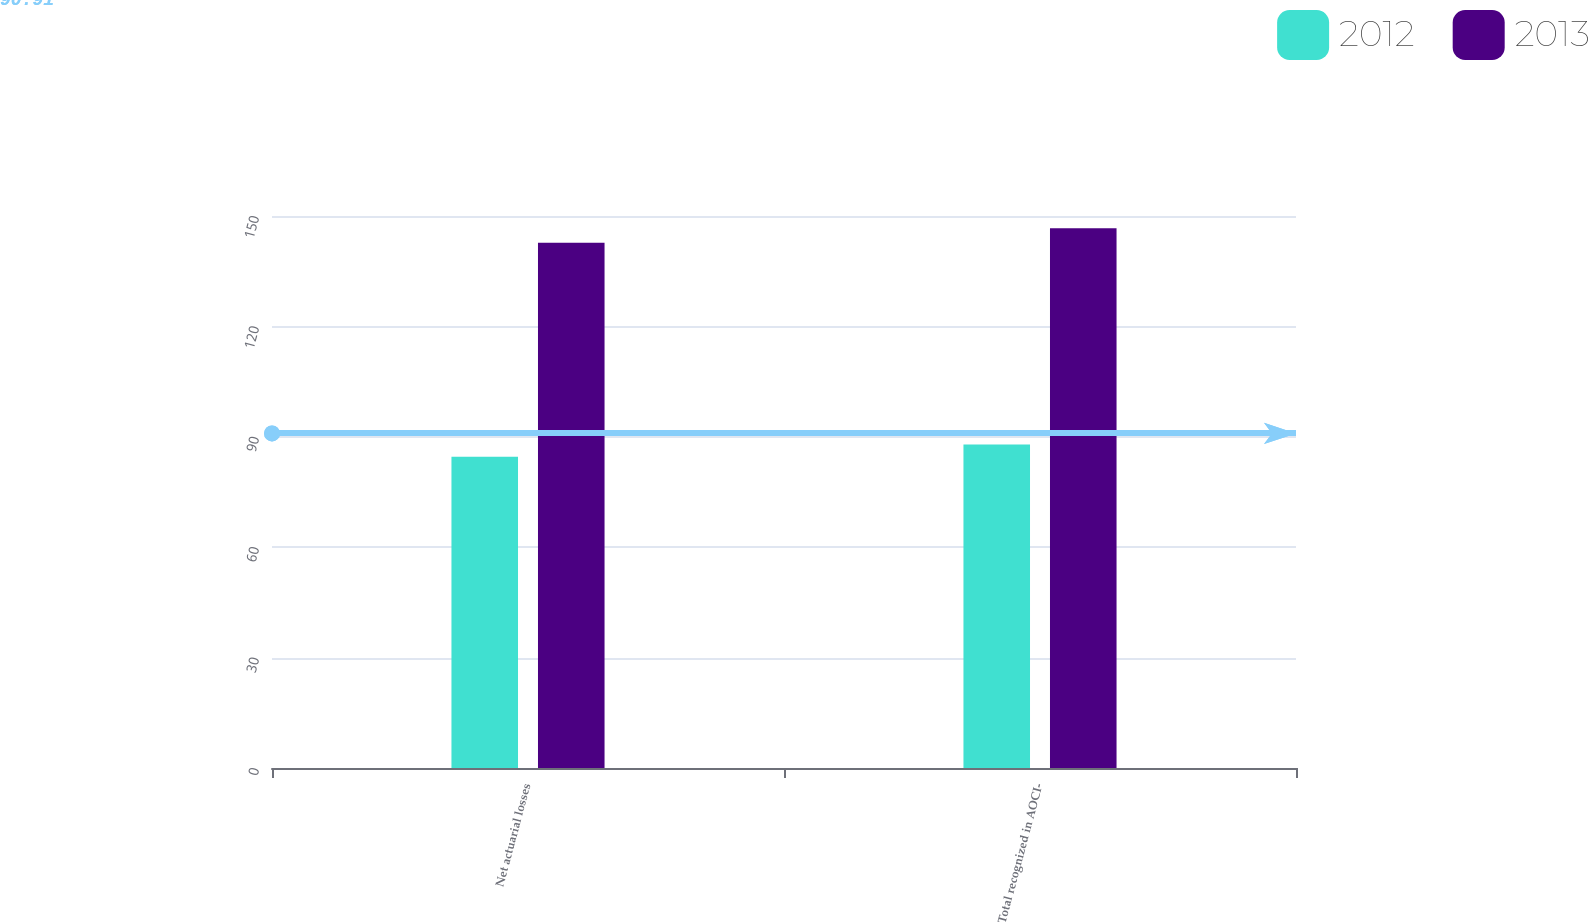Convert chart. <chart><loc_0><loc_0><loc_500><loc_500><stacked_bar_chart><ecel><fcel>Net actuarial losses<fcel>Total recognized in AOCI-<nl><fcel>2012<fcel>84.6<fcel>87.9<nl><fcel>2013<fcel>142.7<fcel>146.7<nl></chart> 